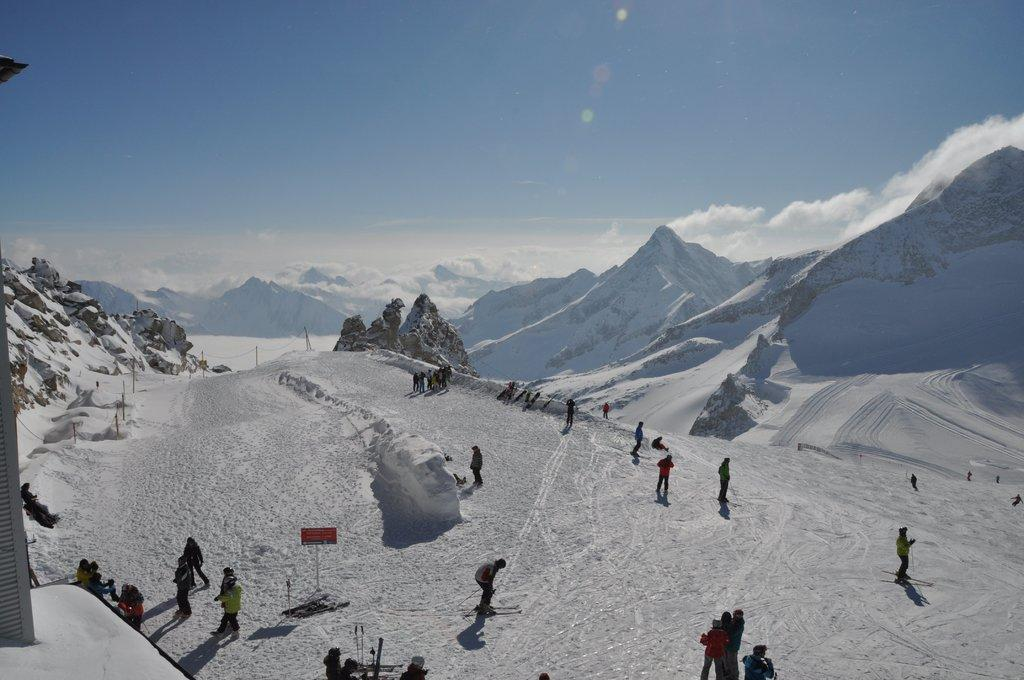Who or what can be seen in the image? There are people in the image. What type of natural formation is visible in the image? There are mountains in the image. What is the weather like in the image? There is snow in the image, indicating a cold climate. What object can be seen in the image? There is a board in the image. What is visible in the background of the image? The sky is visible in the background of the image. Where is the scarecrow located in the image? There is no scarecrow present in the image. What type of jewelry is the person wearing in the image? The provided facts do not mention any jewelry, so it cannot be determined from the image. 